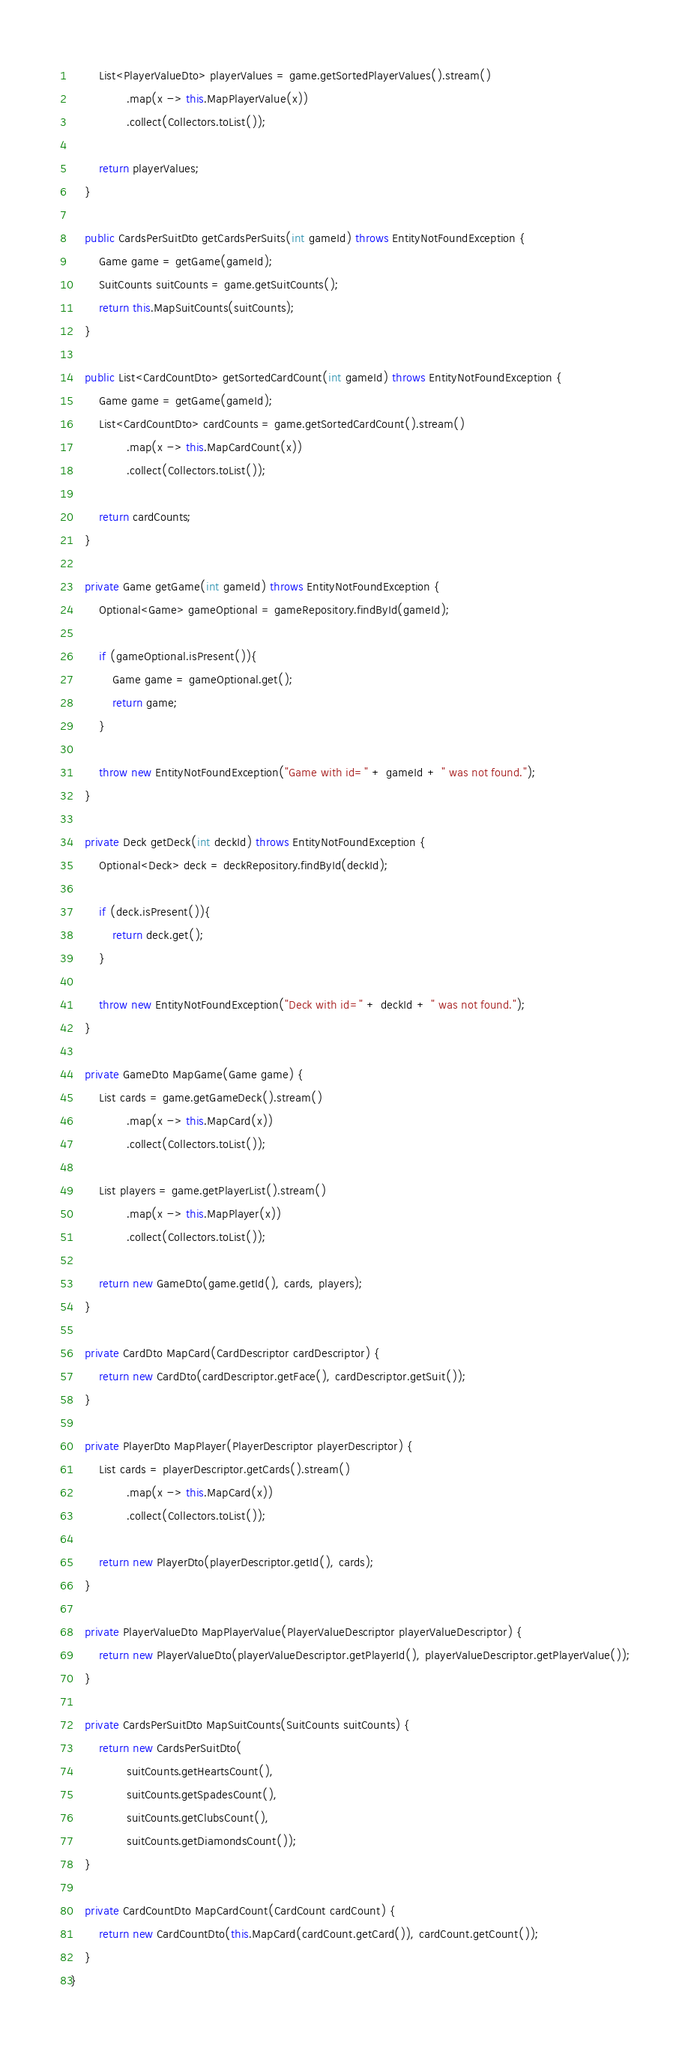<code> <loc_0><loc_0><loc_500><loc_500><_Java_>
        List<PlayerValueDto> playerValues = game.getSortedPlayerValues().stream()
                .map(x -> this.MapPlayerValue(x))
                .collect(Collectors.toList());

        return playerValues;
    }

    public CardsPerSuitDto getCardsPerSuits(int gameId) throws EntityNotFoundException {
        Game game = getGame(gameId);
        SuitCounts suitCounts = game.getSuitCounts();
        return this.MapSuitCounts(suitCounts);
    }

    public List<CardCountDto> getSortedCardCount(int gameId) throws EntityNotFoundException {
        Game game = getGame(gameId);
        List<CardCountDto> cardCounts = game.getSortedCardCount().stream()
                .map(x -> this.MapCardCount(x))
                .collect(Collectors.toList());

        return cardCounts;
    }

    private Game getGame(int gameId) throws EntityNotFoundException {
        Optional<Game> gameOptional = gameRepository.findById(gameId);

        if (gameOptional.isPresent()){
            Game game = gameOptional.get();
            return game;
        }

        throw new EntityNotFoundException("Game with id=" + gameId + " was not found.");
    }

    private Deck getDeck(int deckId) throws EntityNotFoundException {
        Optional<Deck> deck = deckRepository.findById(deckId);

        if (deck.isPresent()){
            return deck.get();
        }

        throw new EntityNotFoundException("Deck with id=" + deckId + " was not found.");
    }

    private GameDto MapGame(Game game) {
        List cards = game.getGameDeck().stream()
                .map(x -> this.MapCard(x))
                .collect(Collectors.toList());

        List players = game.getPlayerList().stream()
                .map(x -> this.MapPlayer(x))
                .collect(Collectors.toList());

        return new GameDto(game.getId(), cards, players);
    }

    private CardDto MapCard(CardDescriptor cardDescriptor) {
        return new CardDto(cardDescriptor.getFace(), cardDescriptor.getSuit());
    }

    private PlayerDto MapPlayer(PlayerDescriptor playerDescriptor) {
        List cards = playerDescriptor.getCards().stream()
                .map(x -> this.MapCard(x))
                .collect(Collectors.toList());

        return new PlayerDto(playerDescriptor.getId(), cards);
    }

    private PlayerValueDto MapPlayerValue(PlayerValueDescriptor playerValueDescriptor) {
        return new PlayerValueDto(playerValueDescriptor.getPlayerId(), playerValueDescriptor.getPlayerValue());
    }

    private CardsPerSuitDto MapSuitCounts(SuitCounts suitCounts) {
        return new CardsPerSuitDto(
                suitCounts.getHeartsCount(),
                suitCounts.getSpadesCount(),
                suitCounts.getClubsCount(),
                suitCounts.getDiamondsCount());
    }

    private CardCountDto MapCardCount(CardCount cardCount) {
        return new CardCountDto(this.MapCard(cardCount.getCard()), cardCount.getCount());
    }
}
</code> 